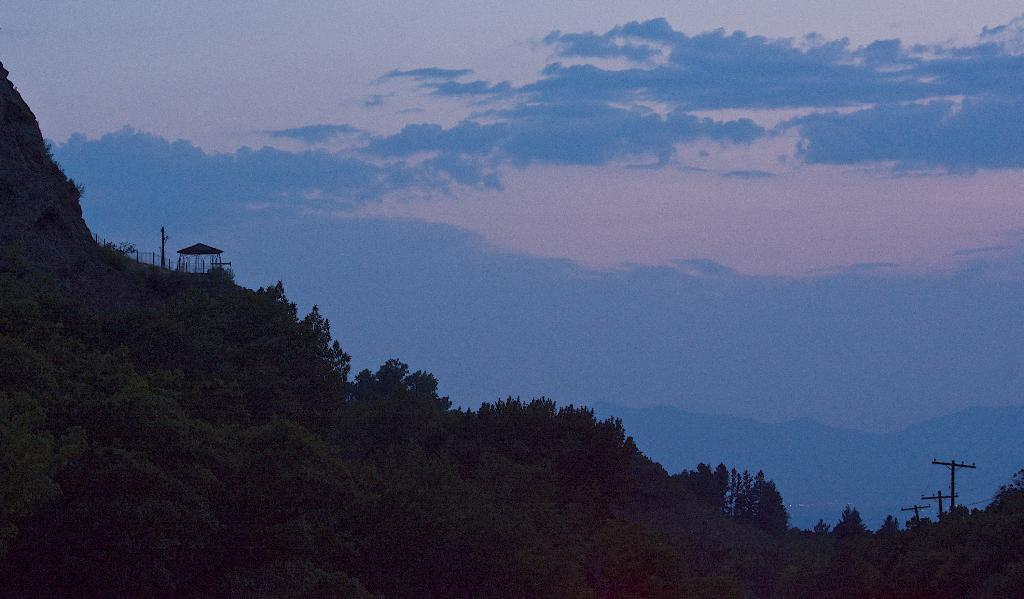What type of vegetation can be seen in the image? There is a group of trees in the image. What structures are present in the image? There are poles in the image. What can be seen in the distance in the image? Mountains are visible in the background of the image. How would you describe the sky in the image? The sky is cloudy in the background of the image. What type of linen is draped over the trees in the image? There is no linen draped over the trees in the image; it only features a group of trees and poles. Can you describe the waves in the image? There are no waves present in the image; it primarily consists of trees, poles, mountains, and a cloudy sky. 